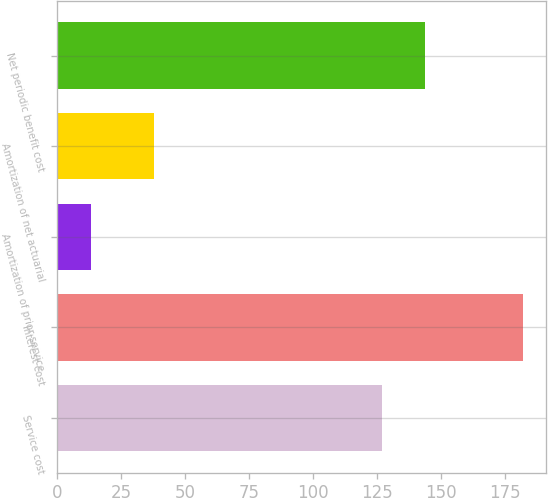Convert chart. <chart><loc_0><loc_0><loc_500><loc_500><bar_chart><fcel>Service cost<fcel>Interest cost<fcel>Amortization of prior service<fcel>Amortization of net actuarial<fcel>Net periodic benefit cost<nl><fcel>127<fcel>182<fcel>13<fcel>38<fcel>143.9<nl></chart> 